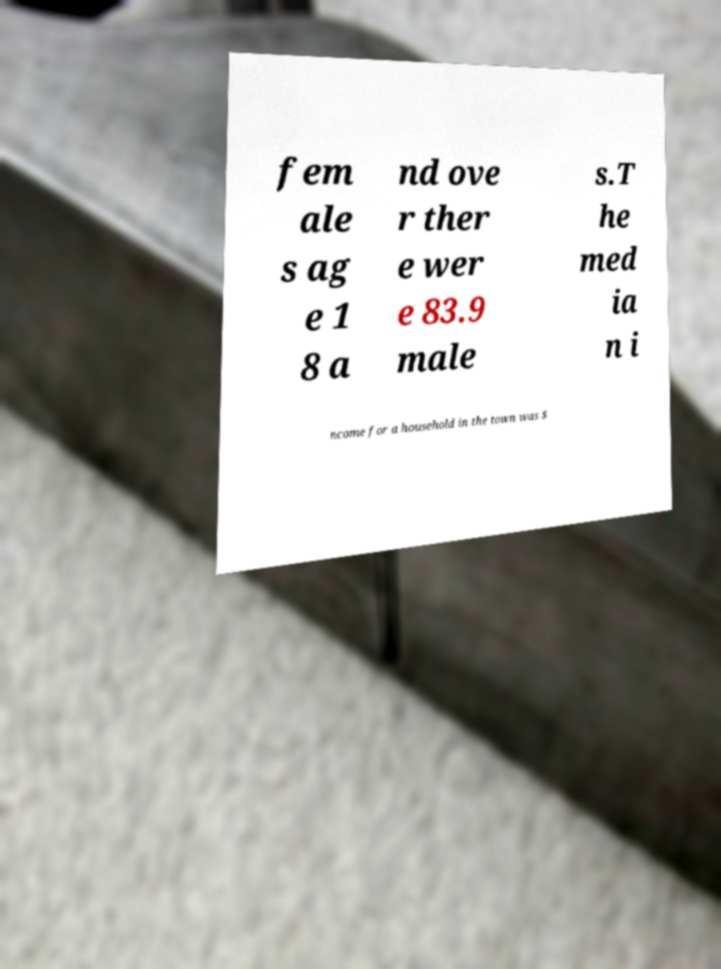Could you assist in decoding the text presented in this image and type it out clearly? fem ale s ag e 1 8 a nd ove r ther e wer e 83.9 male s.T he med ia n i ncome for a household in the town was $ 